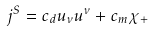<formula> <loc_0><loc_0><loc_500><loc_500>j ^ { S } = c _ { d } u _ { \nu } u ^ { \nu } + c _ { m } { \chi } _ { + }</formula> 